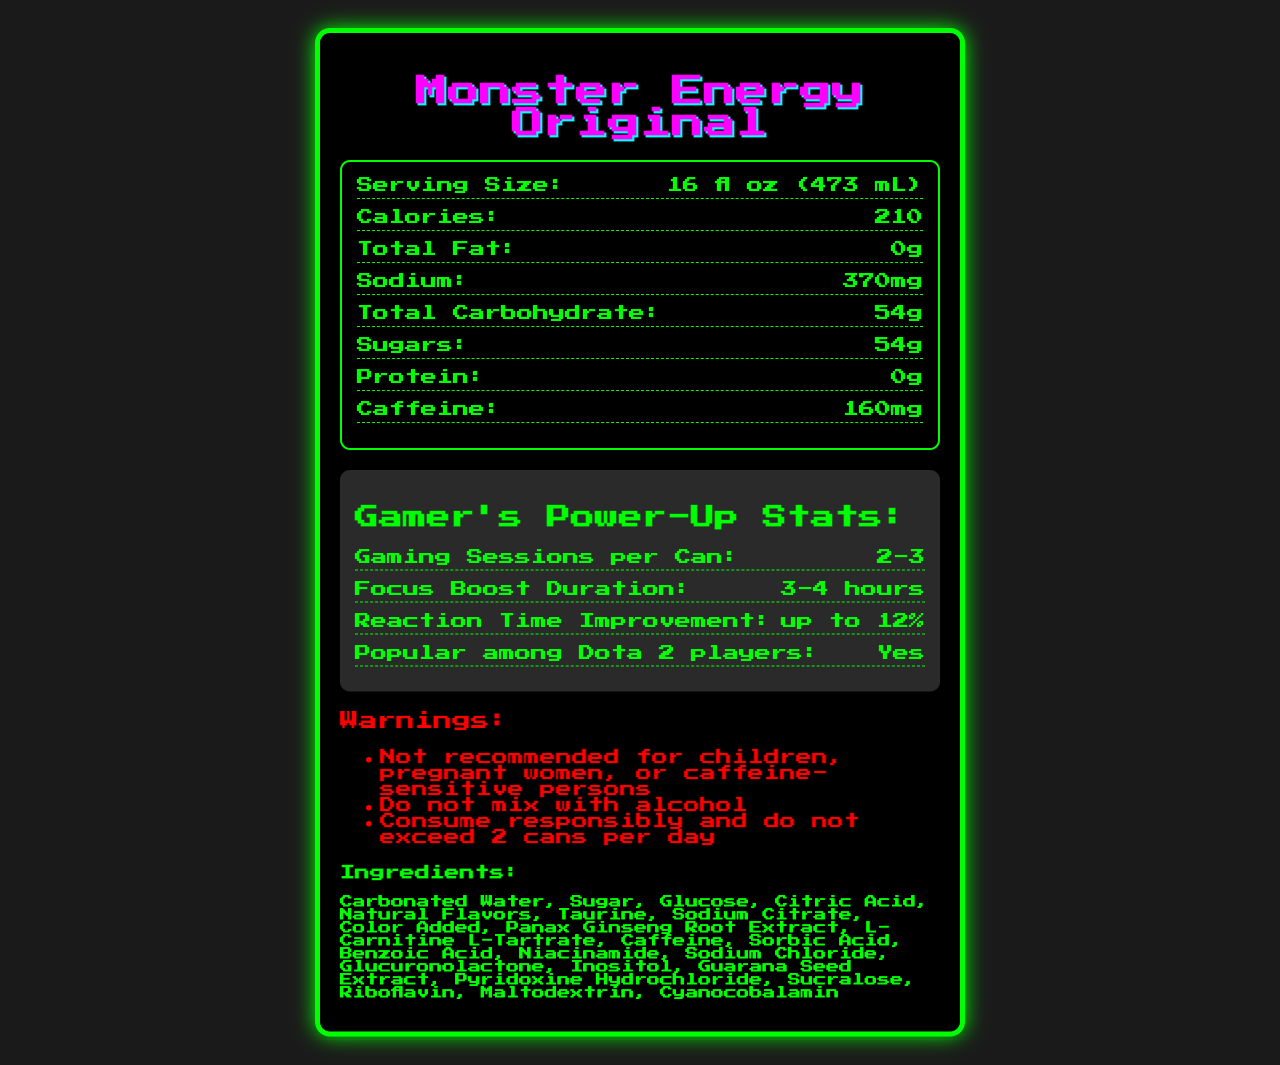what is the caffeine content per serving? The document lists the caffeine content as 160mg.
Answer: 160mg how many grams of sugar are in one serving? The nutrition facts state that there are 54 grams of sugar in one serving.
Answer: 54g what is the serving size for this product? The serving size is clearly mentioned as 16 fl oz (473 mL).
Answer: 16 fl oz (473 mL) how many calories are in one container? The number of calories per container is listed as 210.
Answer: 210 what is the amount of sodium per serving? The sodium content per serving is noted as 370mg.
Answer: 370mg how long will the focus boost last after consuming one can? The gamer-specific information section says the focus boost duration is 3-4 hours.
Answer: 3-4 hours which vitamin has the highest percentage of daily value? 
A. Vitamin B3 
B. Vitamin B6 
C. Vitamin B12 
D. Vitamin C The document lists Vitamin B12 with 200% DV, while Vitamin B3 and B6 also have 200% DV but Vitamin B12 is listed last.
Answer: C. Vitamin B12 how many ingredients are listed in the document?
A. 20 
B. 24 
C. 18 
D. 22 There are 20 ingredients listed in the ingredients section of the document.
Answer: A. 20 is this product recommended for pregnant women? The warnings section explicitly states that it is "Not recommended for children, pregnant women, or caffeine-sensitive persons".
Answer: No summarize the main information about Monster Energy Original from the document. The document showcases the nutritional advantages and components of Monster Energy Original, emphasizing its benefits for gamers and health precautions, providing a comprehensive overview of the product’s nutrition, ingredients, and recommendations.
Answer: Monster Energy Original provides a detailed list of nutritional facts, highlighting its calorie, caffeine, sugar content, and vitamin percentages. The energy drink offers specific benefits for gamers, including focus boost duration and reaction time improvement. It also contains warnings about who should not consume the product, such as children and pregnant women. Additionally, it lists ingredients and emphasizes responsible consumption. how much l-carnitine is in one serving? The document states there is 50mg of L-Carnitine per serving.
Answer: 50mg how many gaming sessions can one can potentially support according to the document? The gamer-specific info mentions that one can supports 2-3 gaming sessions.
Answer: 2-3 what is the reaction time improvement after consuming this product? The gamer-specific information section states that reaction time improvement can be up to 12%.
Answer: up to 12% is carbonated water an ingredient in this product? Carbonated water is listed as the first ingredient.
Answer: Yes how many cans of this energy drink should not be exceeded per day according to the warnings? The warnings section advises not to exceed 2 cans per day.
Answer: 2 cans what color scheme is used in this document's design? The specific color scheme of the document is not mentioned, so it cannot be determined from the document alone.
Answer: Not enough information 